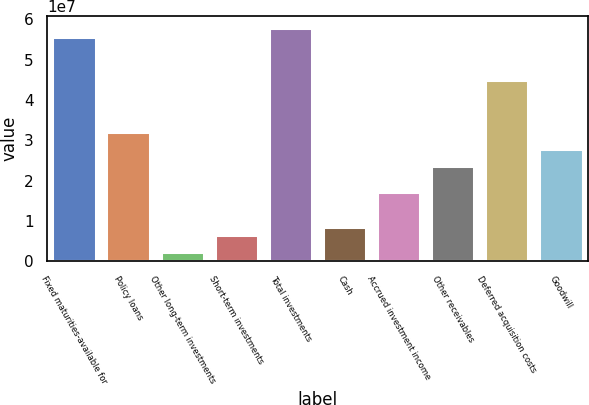Convert chart. <chart><loc_0><loc_0><loc_500><loc_500><bar_chart><fcel>Fixed maturities-available for<fcel>Policy loans<fcel>Other long-term investments<fcel>Short-term investments<fcel>Total investments<fcel>Cash<fcel>Accrued investment income<fcel>Other receivables<fcel>Deferred acquisition costs<fcel>Goodwill<nl><fcel>5.56899e+07<fcel>3.21404e+07<fcel>2.16829e+06<fcel>6.45002e+06<fcel>5.78308e+07<fcel>8.59089e+06<fcel>1.71544e+07<fcel>2.3577e+07<fcel>4.49856e+07<fcel>2.78587e+07<nl></chart> 